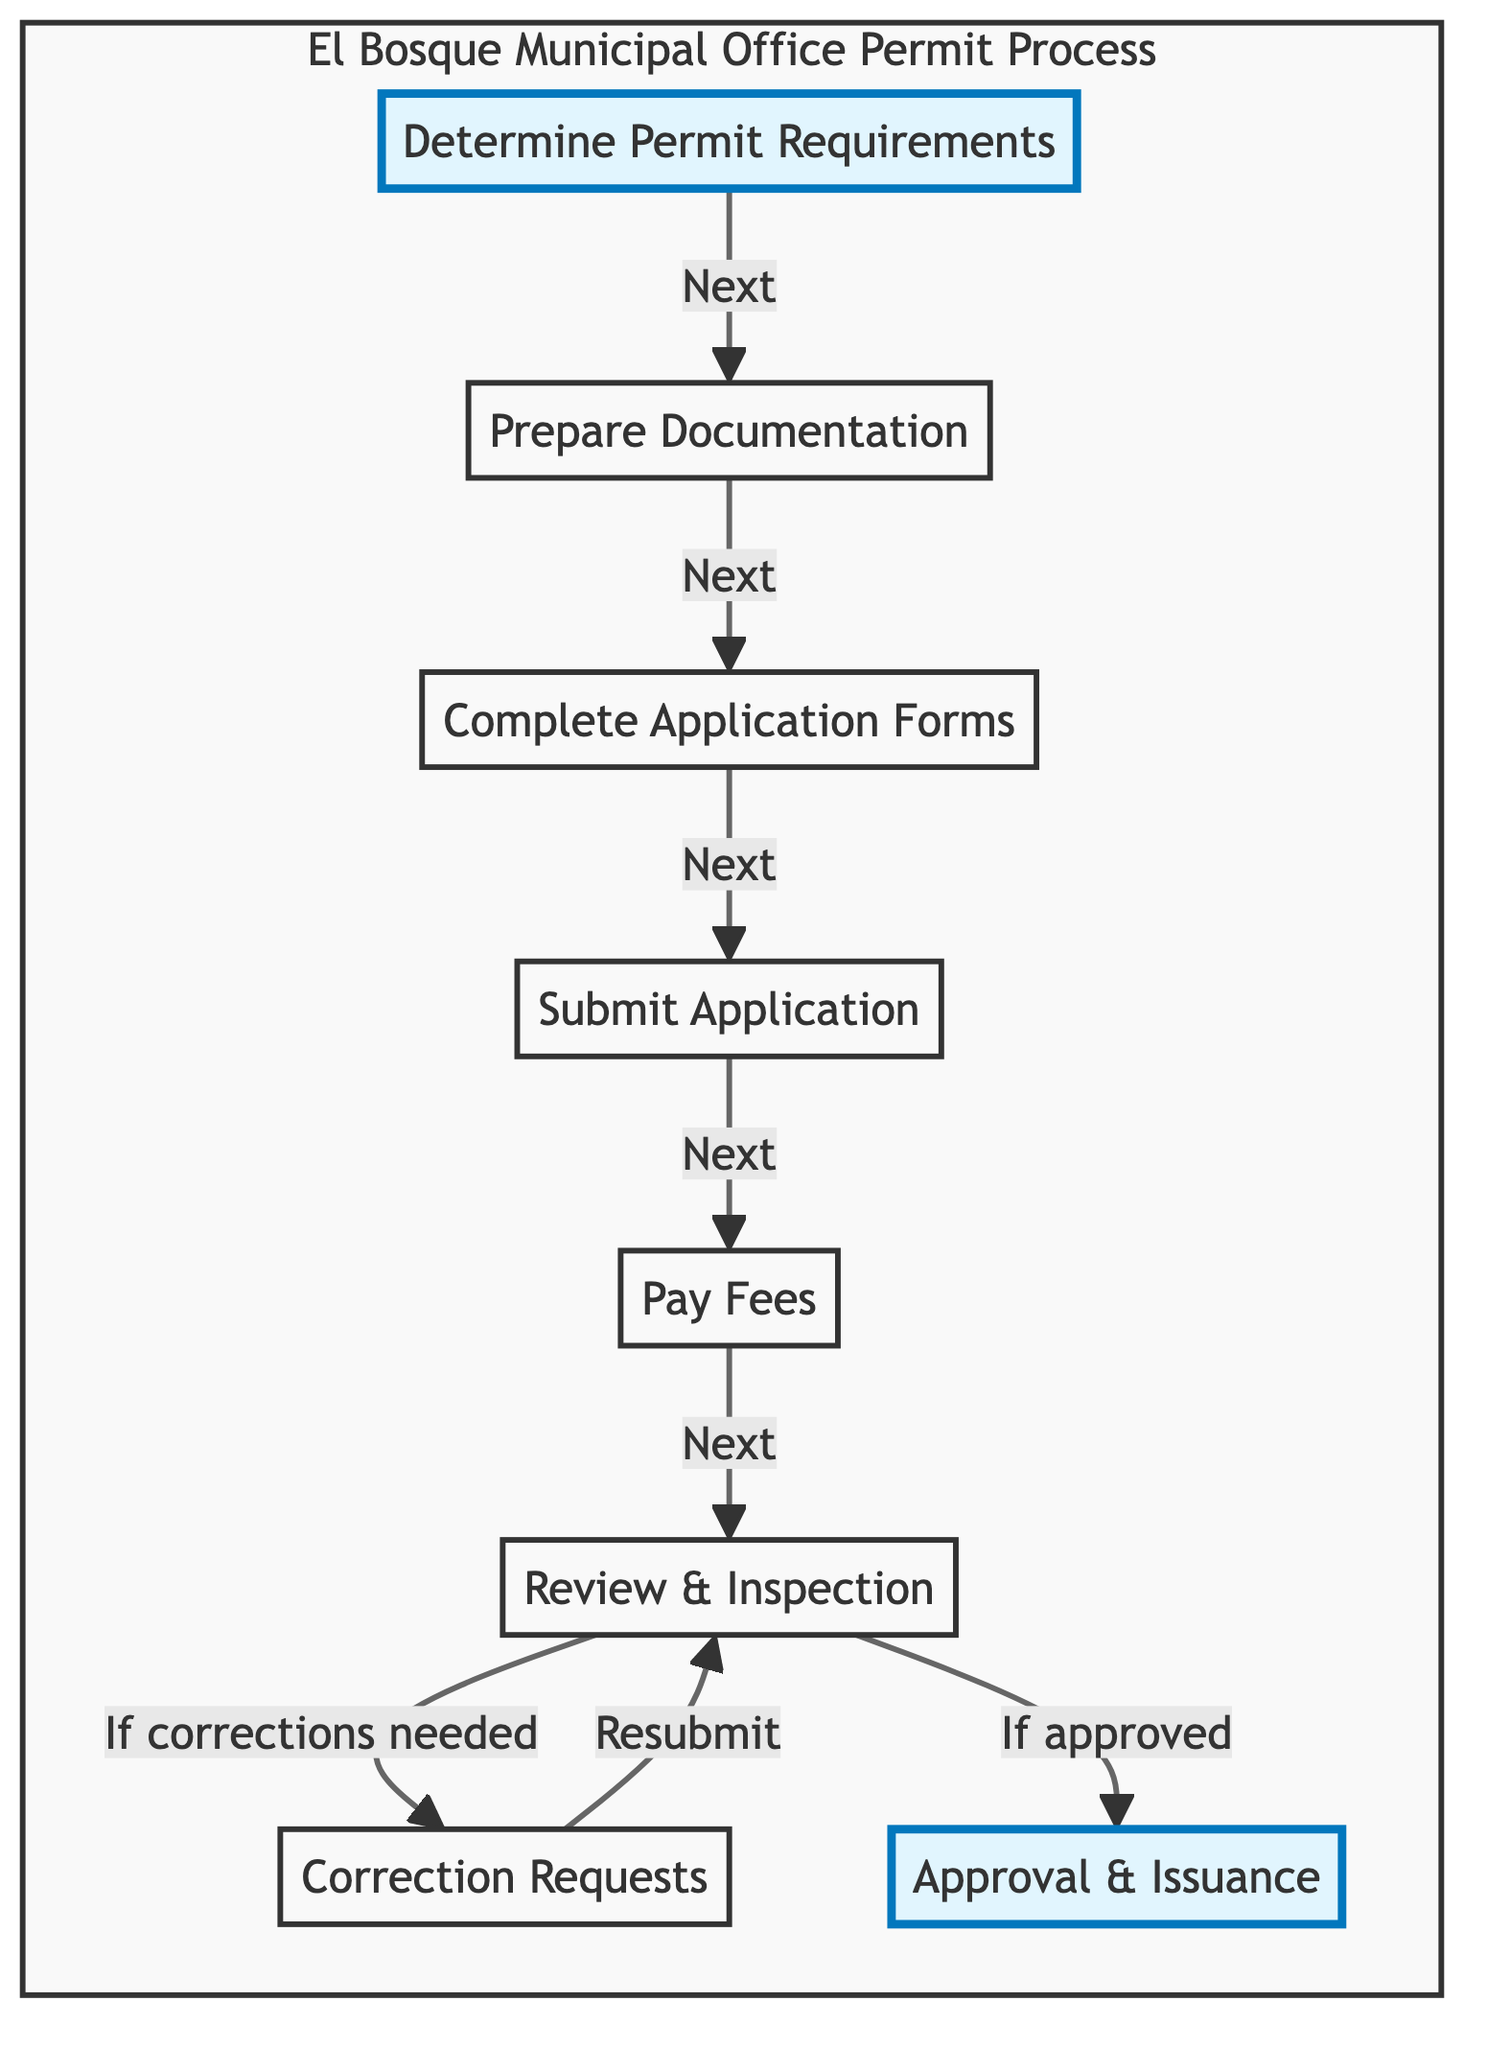What is the first step to apply for a permit? The flowchart starts with the first node labeled "Determine Permit Requirements." This is clearly indicated as the first step in the process.
Answer: Determine Permit Requirements What is the last step of the application process? The final step in the flowchart is labeled "Approval & Issuance." This indicates the end of the permit application process.
Answer: Approval & Issuance How many total steps are there in the diagram? By counting each node from the beginning to the end on the flowchart, there are a total of 8 steps represented.
Answer: 8 What is required after the 'Review & Inspection' step if there are correction requests? If there are correction requests noted after the 'Review & Inspection' step, the next step indicates to address the requests and resubmit the application, which goes back to step 'Review & Inspection.'
Answer: Correction Requests Which step involves paying fees? The step indicated as "Pay Fees" directly follows the submission of the application, which clearly identifies that this is where the fees must be paid.
Answer: Pay Fees What happens if the application is approved after the 'Review & Inspection'? The flowchart shows that if the application is approved, the next step is to receive approval and get the permit issued, thus indicating the successful completion of the application process.
Answer: Approval & Issuance From which step does the flowchart return to 'Review & Inspection'? The flowchart indicates that it returns to 'Review & Inspection' from the step 'Correction Requests' if there are any correction requests that must be addressed.
Answer: Correction Requests Which step requires gathering property plans and blueprints? The step that specifies the gathering of necessary documents, including property plans and project blueprints, is labeled "Prepare Documentation." This is clearly defined as the second step.
Answer: Prepare Documentation 